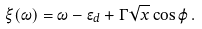Convert formula to latex. <formula><loc_0><loc_0><loc_500><loc_500>\xi ( \omega ) = \omega - \epsilon _ { d } + \Gamma \sqrt { x } \cos \varphi \, .</formula> 